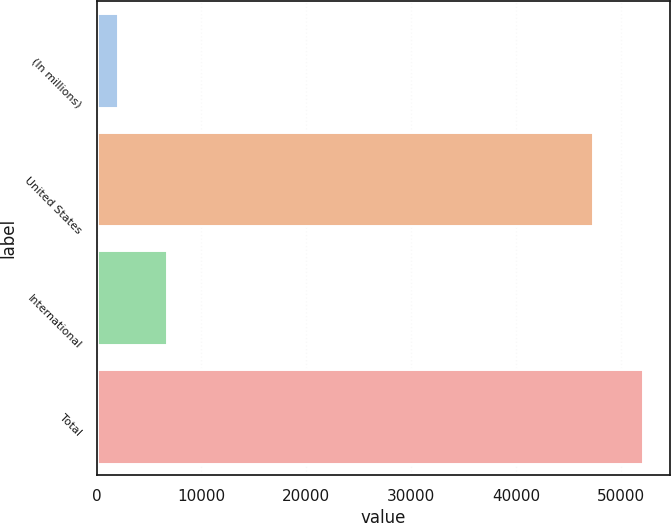Convert chart. <chart><loc_0><loc_0><loc_500><loc_500><bar_chart><fcel>(In millions)<fcel>United States<fcel>International<fcel>Total<nl><fcel>2004<fcel>47354<fcel>6750.1<fcel>52100.1<nl></chart> 